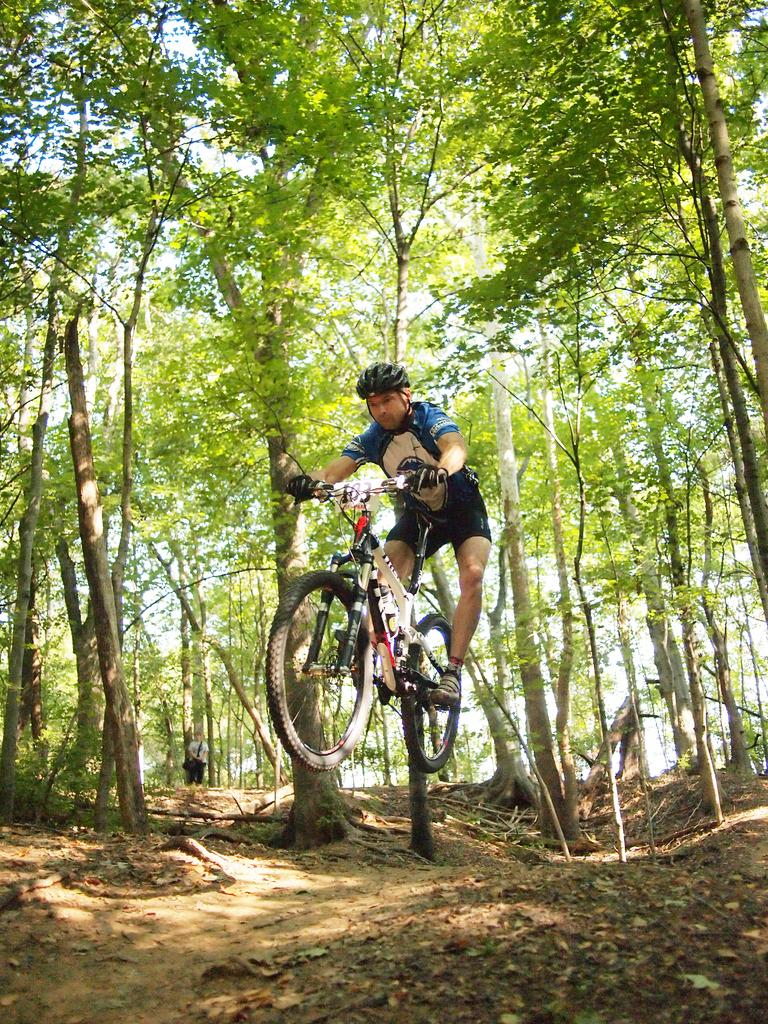Who or what is the main subject in the image? There is a person in the image. What is the person doing in the image? The person is riding a bicycle. What can be seen in the background of the image? There are trees visible in the image. How many dolls are sitting on the bicycle with the person in the image? There are no dolls present in the image; it features a person riding a bicycle. Can you see a squirrel climbing one of the trees in the background of the image? There is no squirrel visible in the image; only trees are mentioned in the background. 